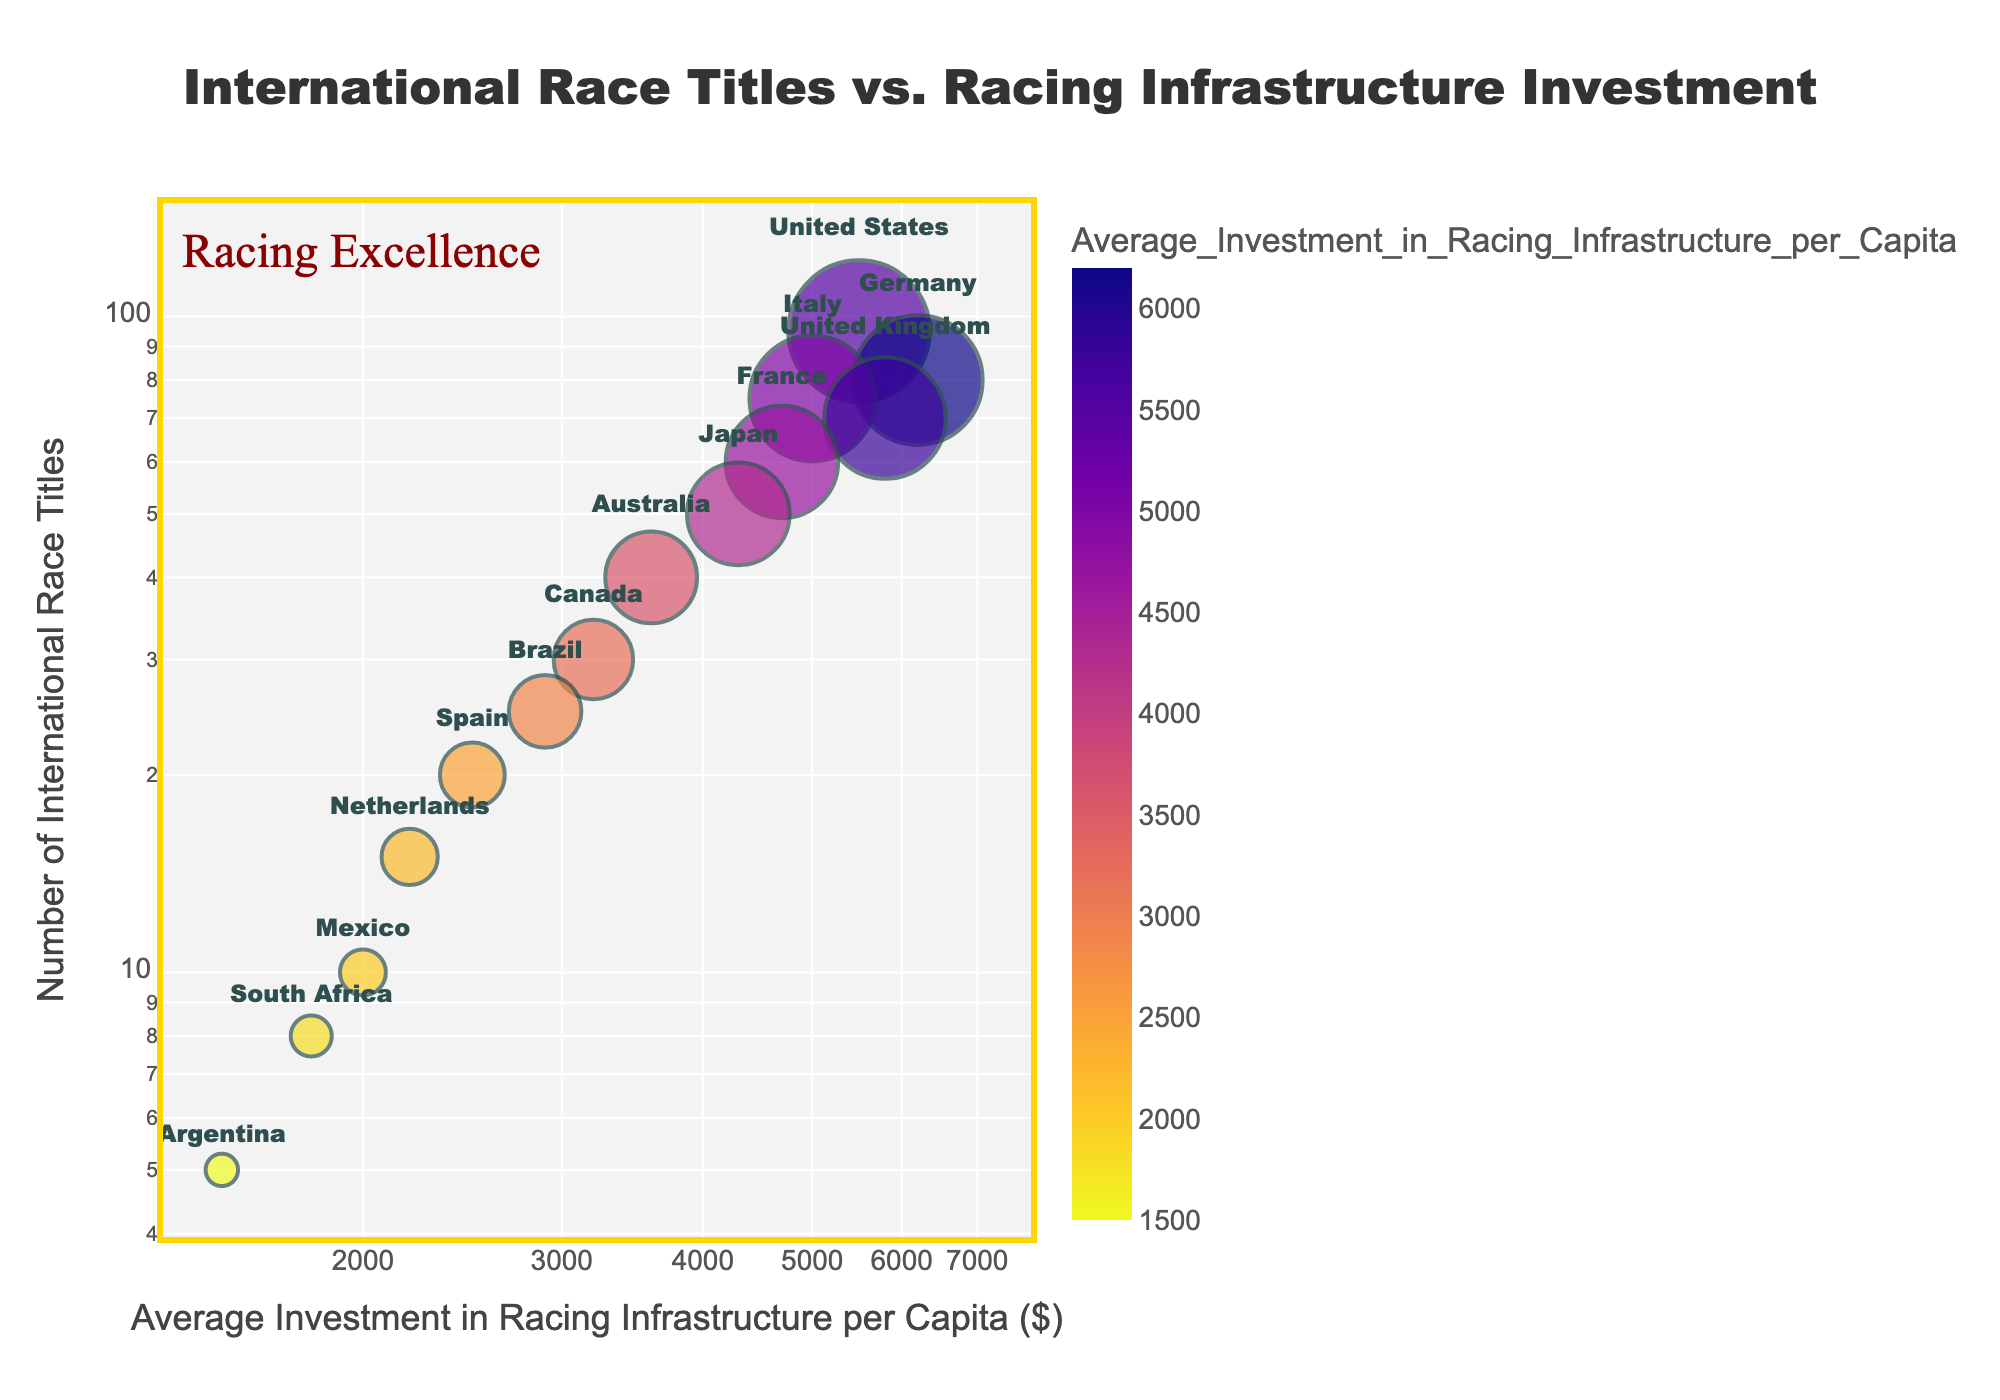What is the title of the scatter plot? The title is located at the top center of the scatter plot and is framed within a custom rectangle shape.
Answer: International Race Titles vs. Racing Infrastructure Investment Which country has the highest number of international race titles? The country with the highest number of race titles is represented by the largest circle on the plot. This country is labeled directly next to the largest circle.
Answer: United States Which country has the lowest average investment in racing infrastructure per capita? The country with the lowest average investment is positioned closest to the left side of the x-axis which represents log scale investment per capita.
Answer: Argentina How many countries have an average investment in racing infrastructure per capita lower than $3000? To find this, count all circles that are located left of the vertical line passing through the $3000 mark on the x-axis (remembering this is a log scale).
Answer: 7 Which country has the highest average investment in racing infrastructure per capita and how many international race titles have they won? Look for the country positioned furthest to the right on the x-axis and note its corresponding y-axis value.
Answer: Germany, 80 Compare the number of international race titles won by Brazil and Spain. Which country has won more titles and by how much? Identify the points representing Brazil and Spain and compare their y-axis values. Brazil is at 25 and Spain is at 20. The difference is 25 - 20 = 5.
Answer: Brazil, by 5 What are the total number of international race titles won by the top three countries combined? Sum up the y-axis values of the top three countries: United States (95), Germany (80), and Italy (75). The total is 95 + 80 + 75 = 250.
Answer: 250 If you point to a country with an investment of $2200, which country are you pointing to and how many titles have they won? Locate the circle closest to the $2200 mark on the x-axis. It is labeled with the country name and its y-axis value indicates the number of titles.
Answer: Netherlands, 15 What trend can you observe in the relationship between average investment in racing infrastructure per capita and the number of international race titles? Observing the scatter plot, notice if the data points show a general trend where higher investments tend to correspond to more titles won.
Answer: Higher investment generally correlates with more titles What is the color of the circle representing Australia and how does the size compare with Canada? Find Australia, check its circle color (based on the color scale used) and compare the circle sizes of both countries shown by the area of the circle.
Answer: Plasma color (varies with scale), larger size than Canada 